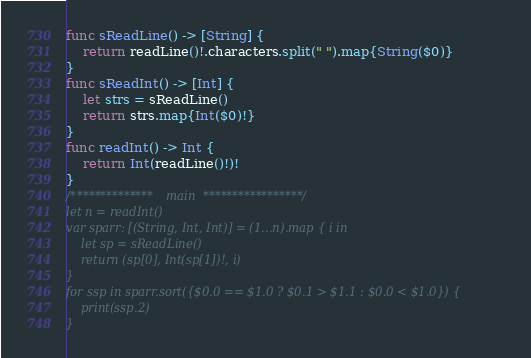<code> <loc_0><loc_0><loc_500><loc_500><_Swift_>func sReadLine() -> [String] {
    return readLine()!.characters.split(" ").map{String($0)}
}
func sReadInt() -> [Int] {
    let strs = sReadLine()
    return strs.map{Int($0)!}
}
func readInt() -> Int {
    return Int(readLine()!)!
}
/************** main *****************/
let n = readInt()
var sparr: [(String, Int, Int)] = (1...n).map { i in
    let sp = sReadLine()
    return (sp[0], Int(sp[1])!, i)
}
for ssp in sparr.sort({$0.0 == $1.0 ? $0.1 > $1.1 : $0.0 < $1.0}) {
    print(ssp.2)
}
</code> 